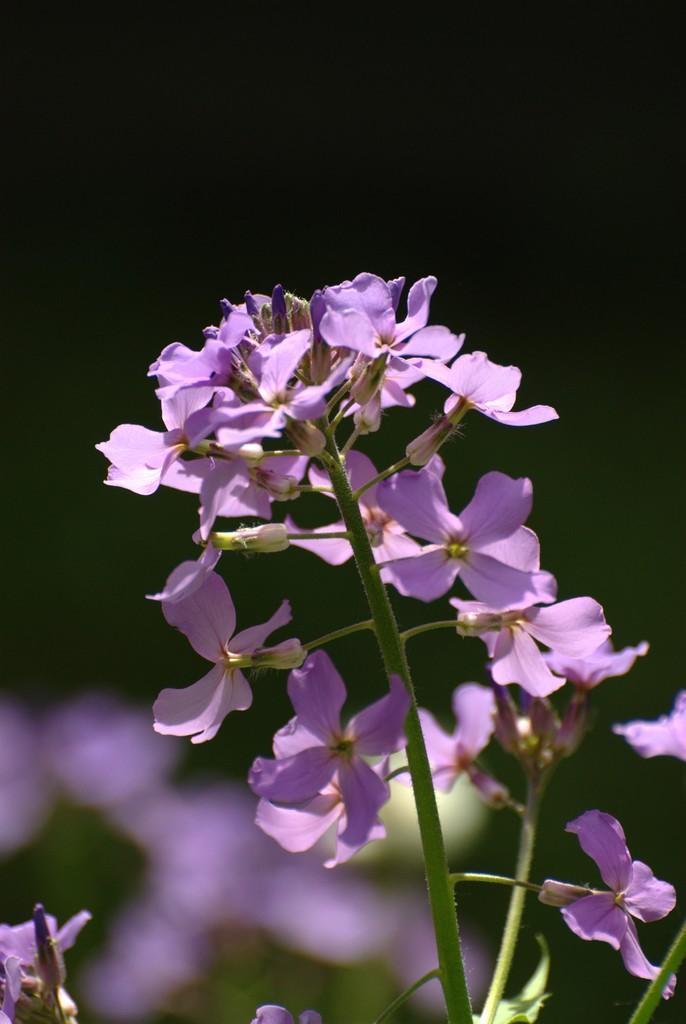Could you give a brief overview of what you see in this image? In this image we can see group of flowers on stems of a plant. 